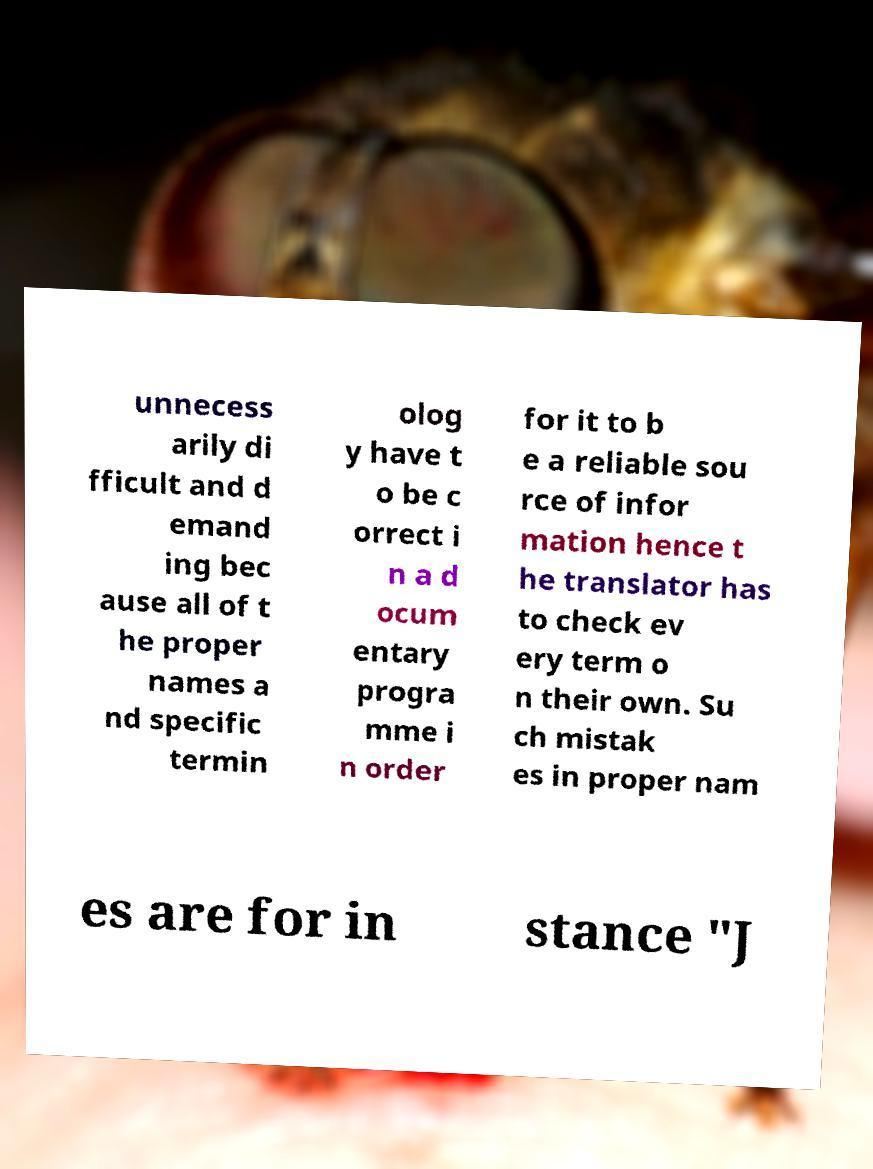Can you read and provide the text displayed in the image?This photo seems to have some interesting text. Can you extract and type it out for me? unnecess arily di fficult and d emand ing bec ause all of t he proper names a nd specific termin olog y have t o be c orrect i n a d ocum entary progra mme i n order for it to b e a reliable sou rce of infor mation hence t he translator has to check ev ery term o n their own. Su ch mistak es in proper nam es are for in stance "J 